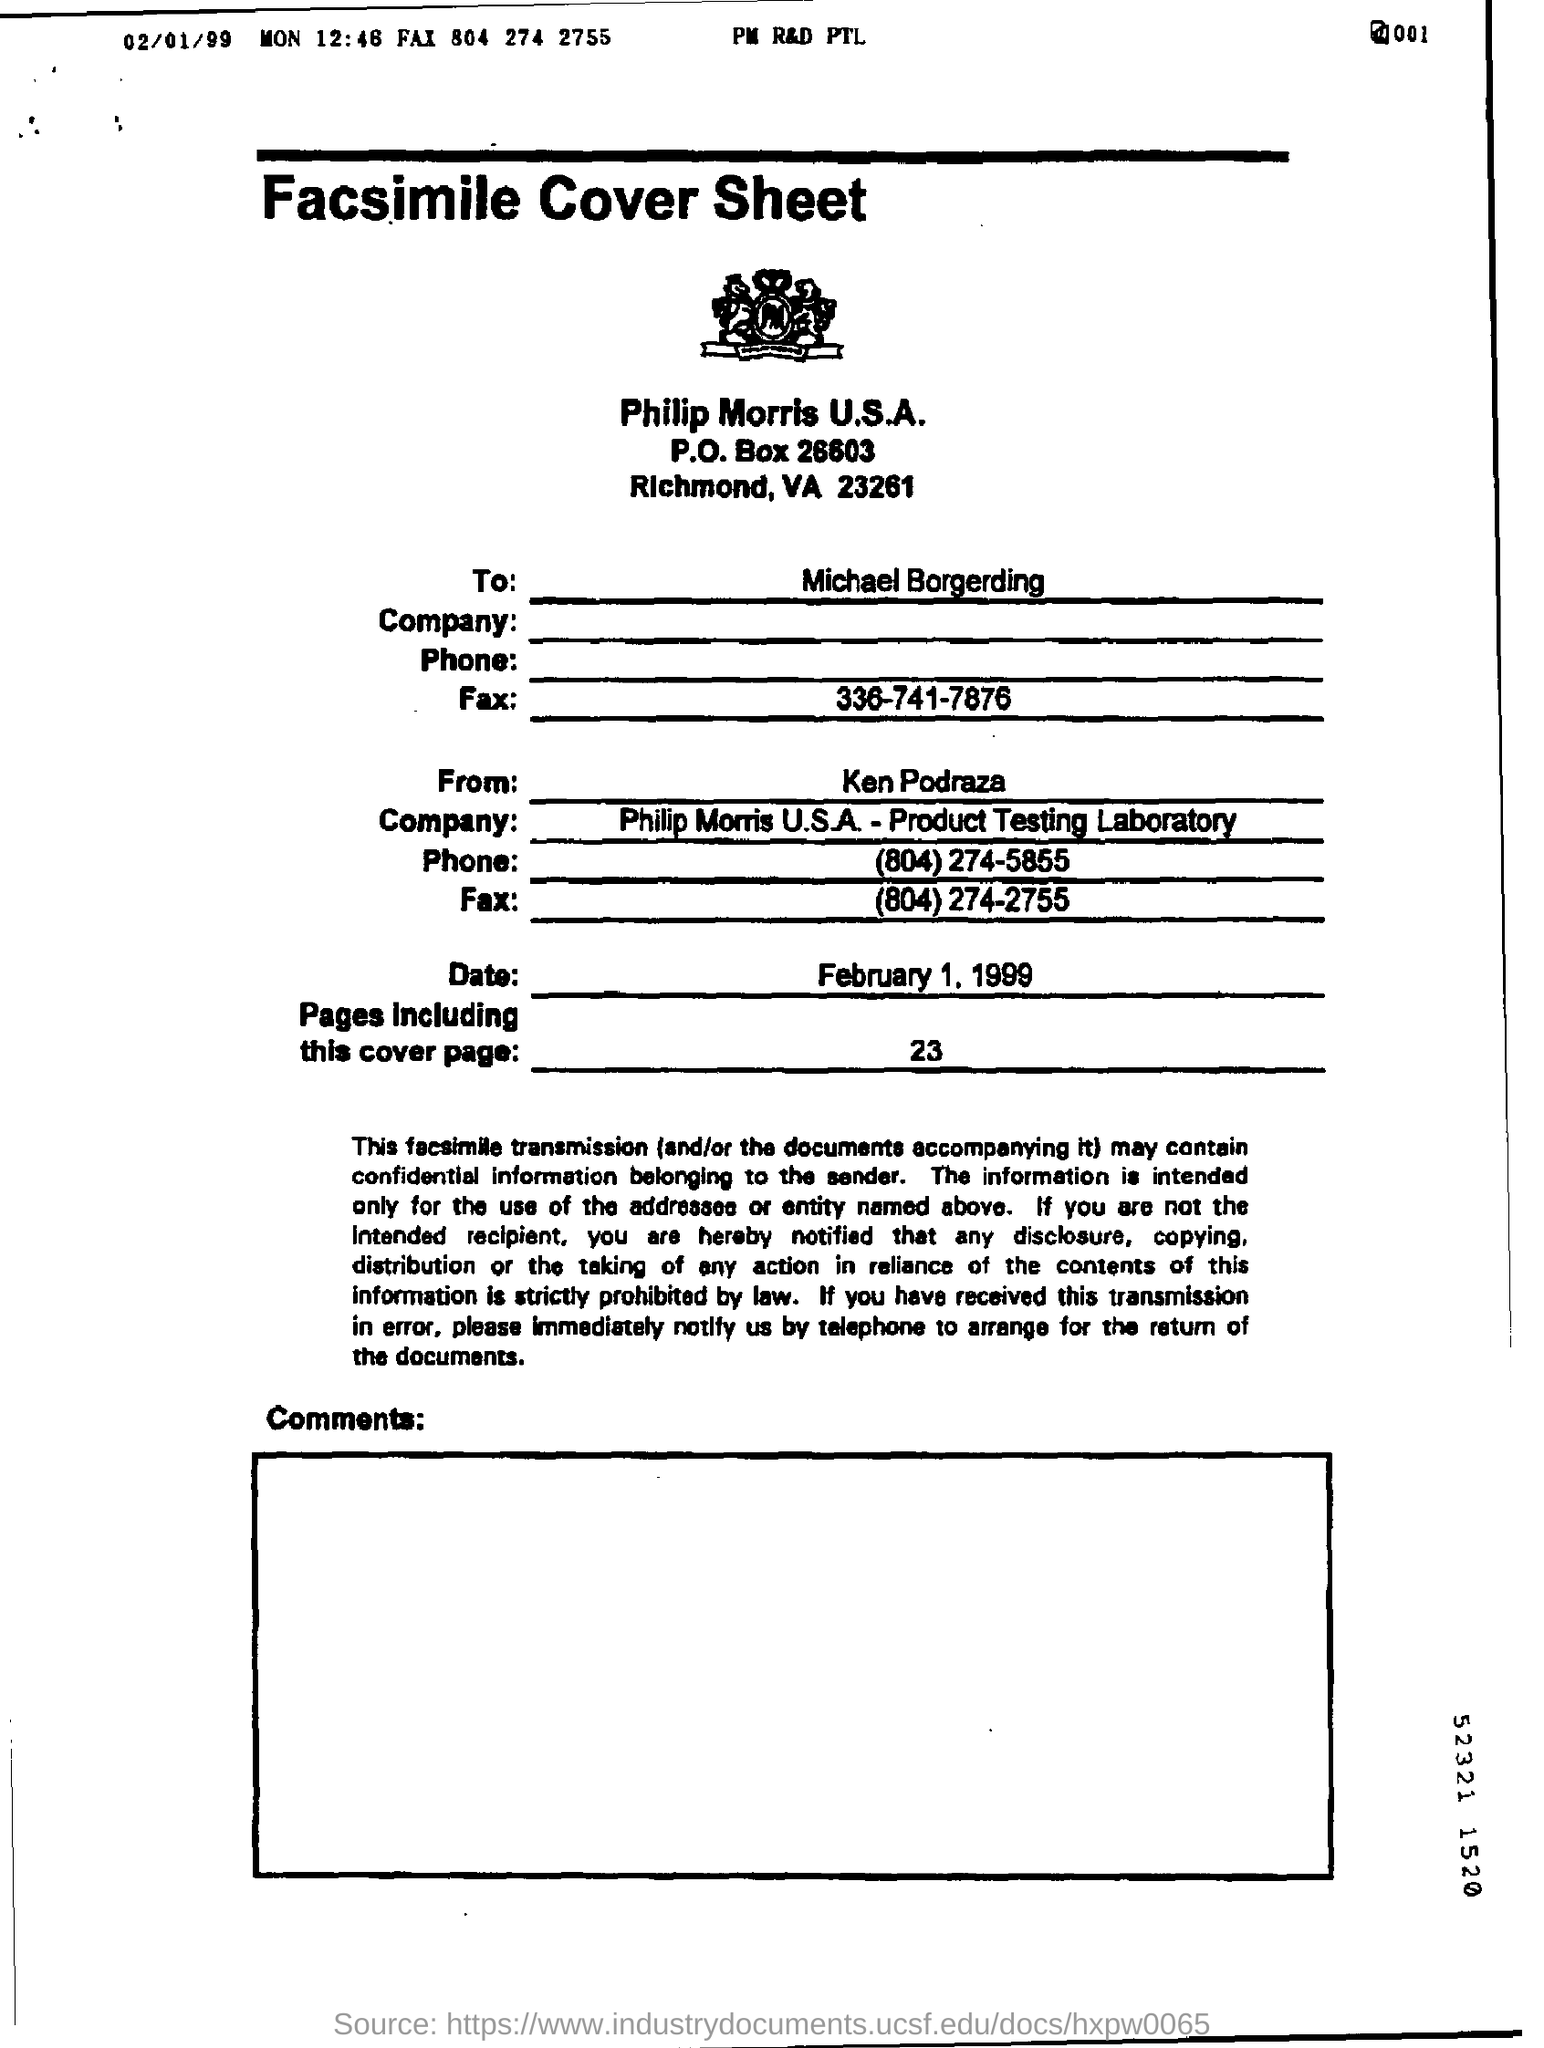What is the fax number that belongs to michael borgerding ?
Provide a short and direct response. 336-741-7876. How many pages are there including this cover page ?
Your answer should be compact. 23. 